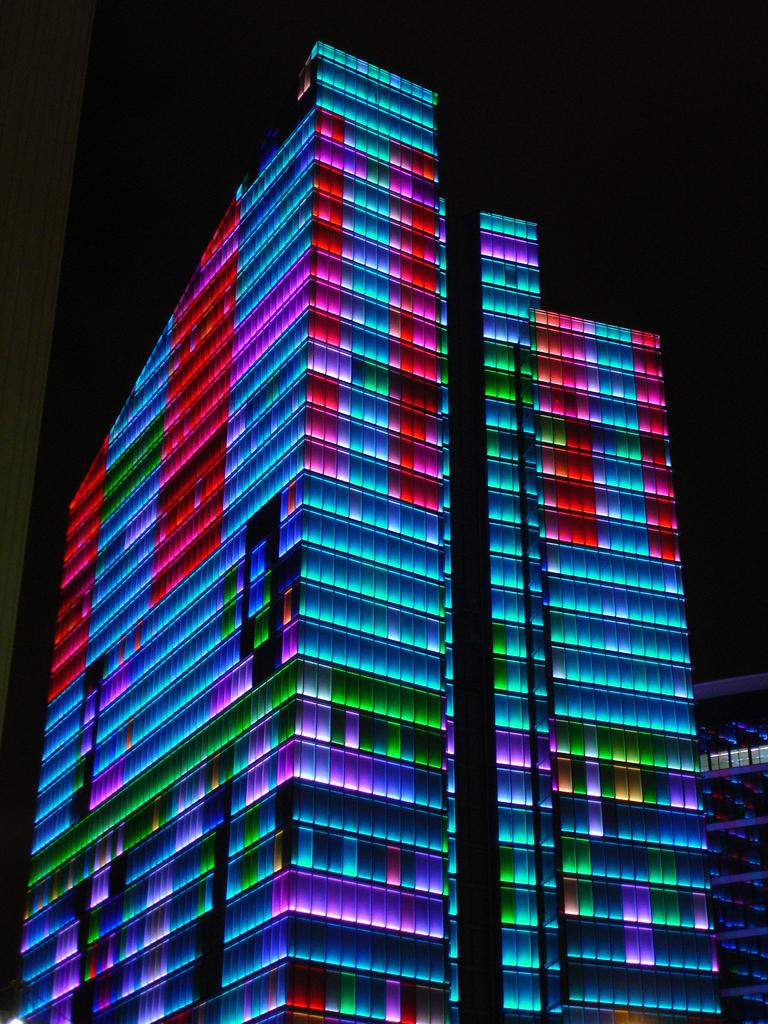What type of structure is visible in the image? There is a building in the image. What feature of the building stands out? The building has colorful lights. What can be observed about the overall lighting in the image? The background of the image is dark. What type of fork can be seen in the image? There is no fork present in the image. How many combs are visible in the image? There are no combs present in the image. 